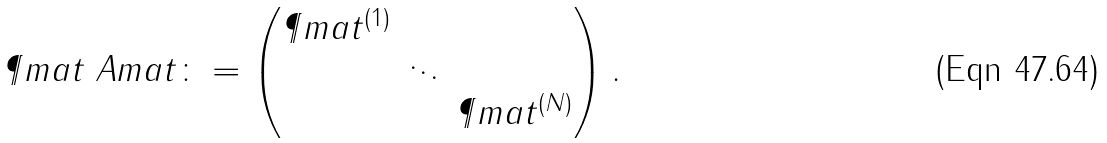Convert formula to latex. <formula><loc_0><loc_0><loc_500><loc_500>\P m a t _ { \ } A m a t \colon = \begin{pmatrix} \P m a t ^ { ( 1 ) } & & \\ & \ddots & \\ & & \P m a t ^ { ( N ) } \end{pmatrix} .</formula> 